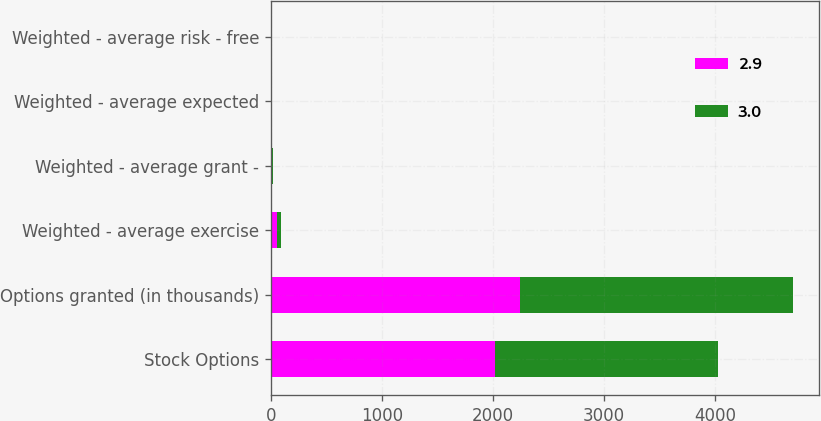<chart> <loc_0><loc_0><loc_500><loc_500><stacked_bar_chart><ecel><fcel>Stock Options<fcel>Options granted (in thousands)<fcel>Weighted - average exercise<fcel>Weighted - average grant -<fcel>Weighted - average expected<fcel>Weighted - average risk - free<nl><fcel>2.9<fcel>2014<fcel>2240<fcel>51.52<fcel>8.74<fcel>2.9<fcel>1.7<nl><fcel>3<fcel>2012<fcel>2456<fcel>39.58<fcel>7.37<fcel>3<fcel>1.1<nl></chart> 